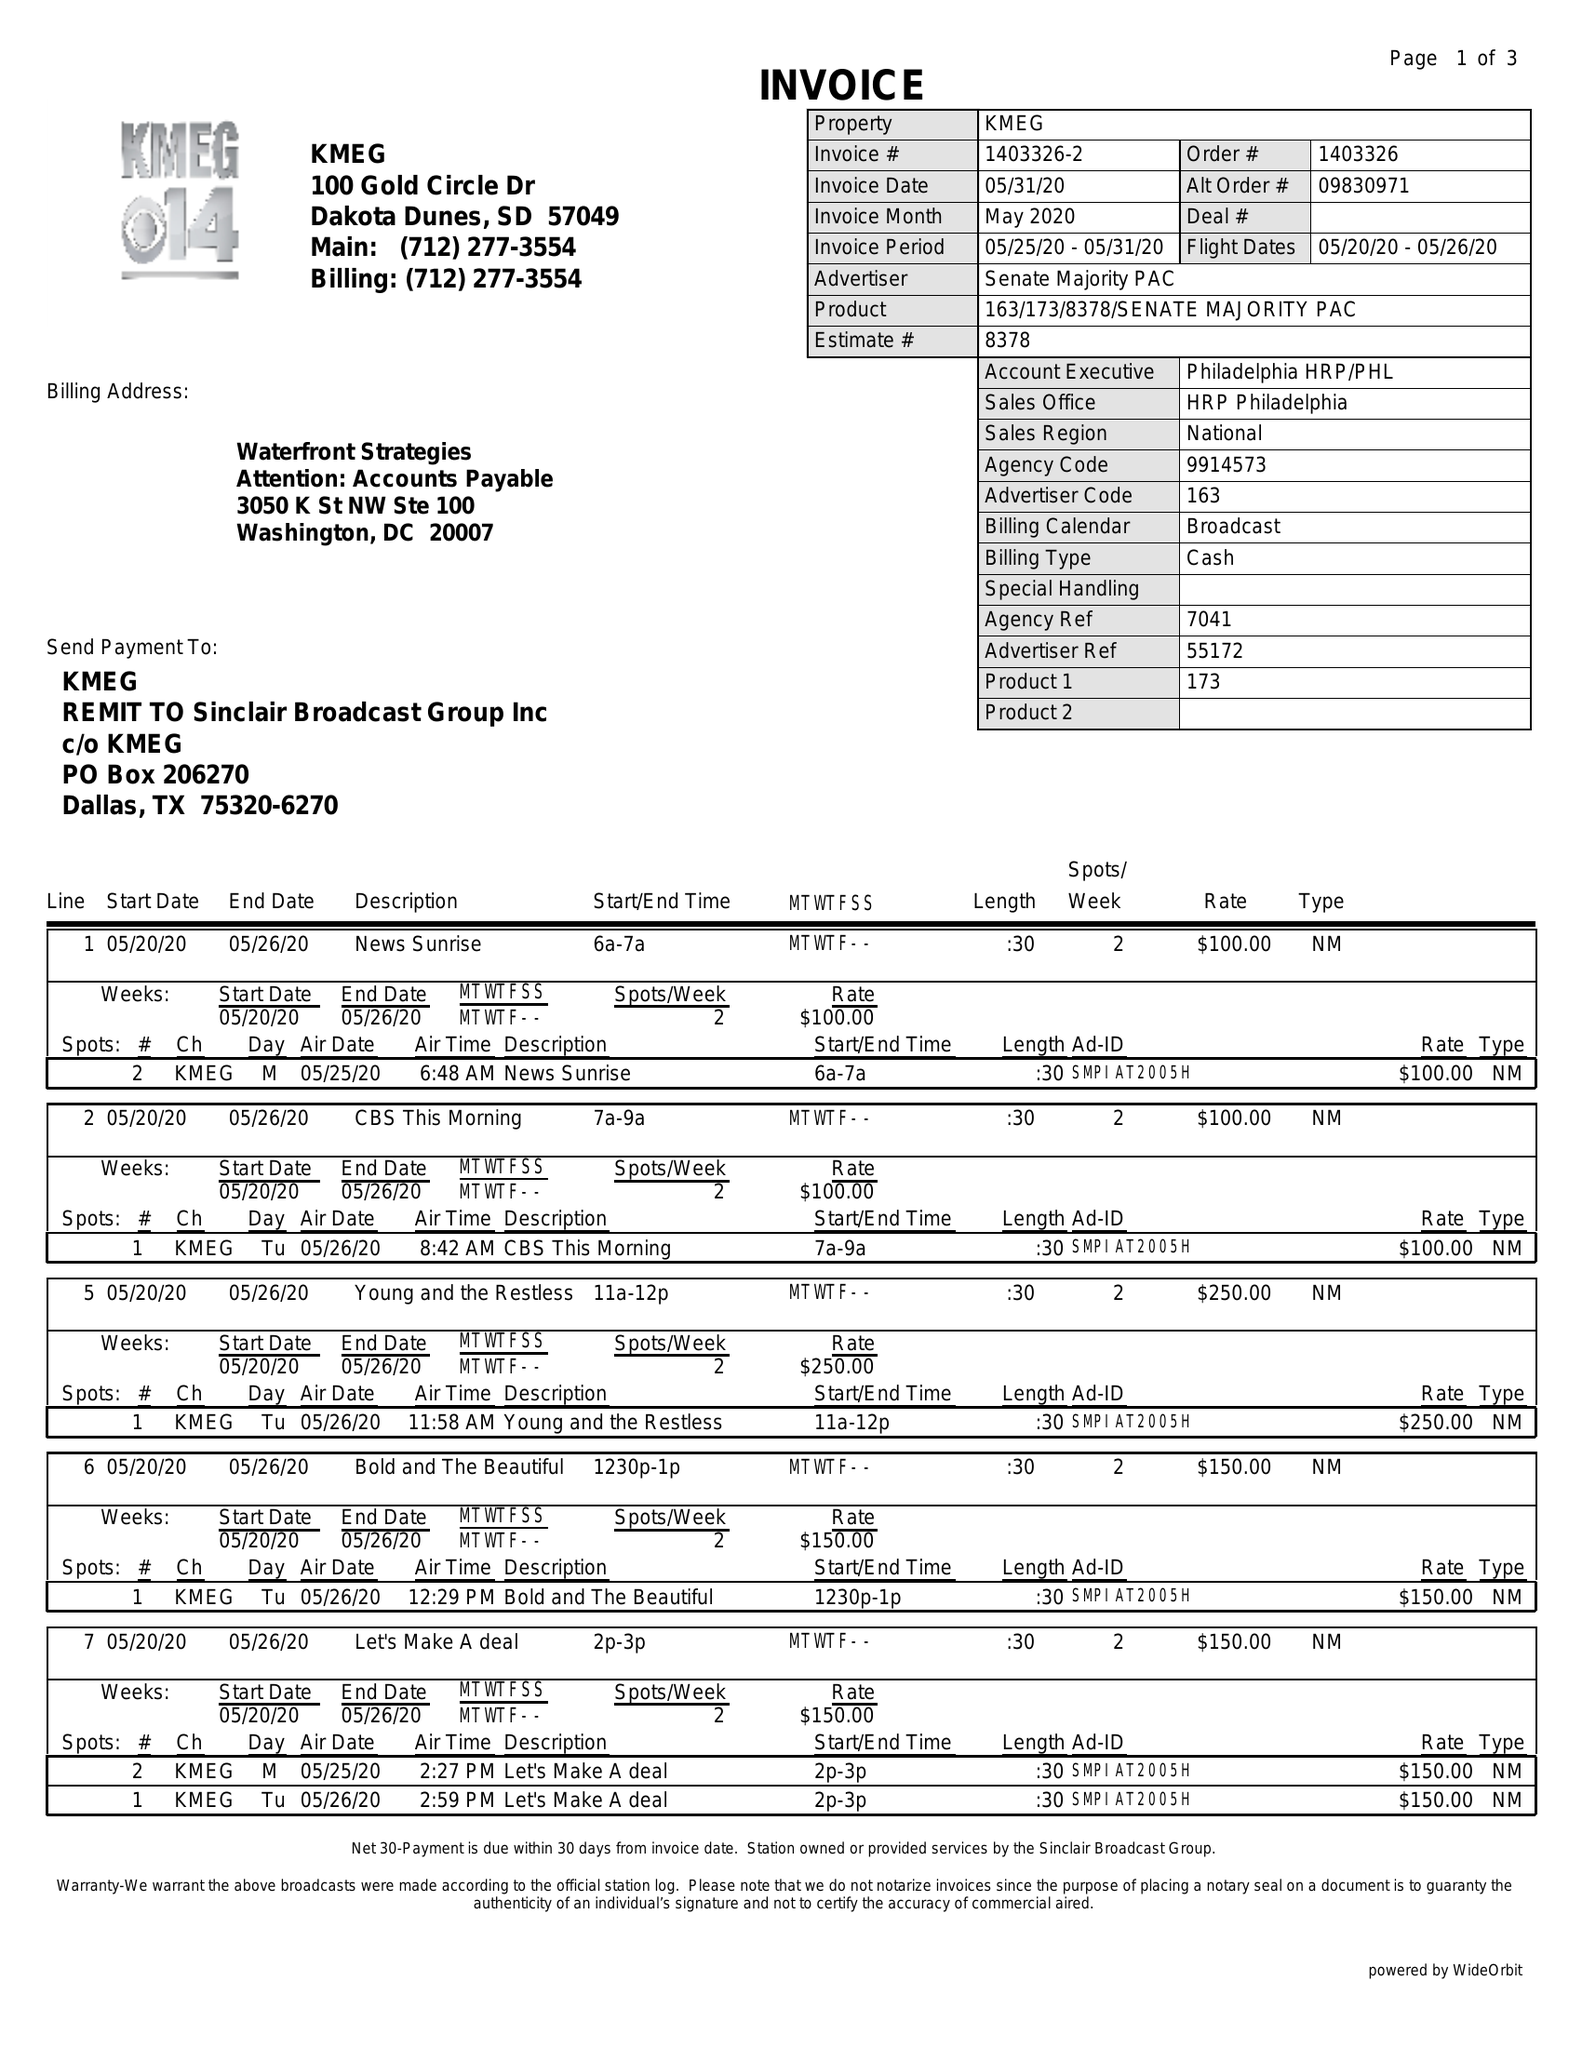What is the value for the contract_num?
Answer the question using a single word or phrase. 1403326 